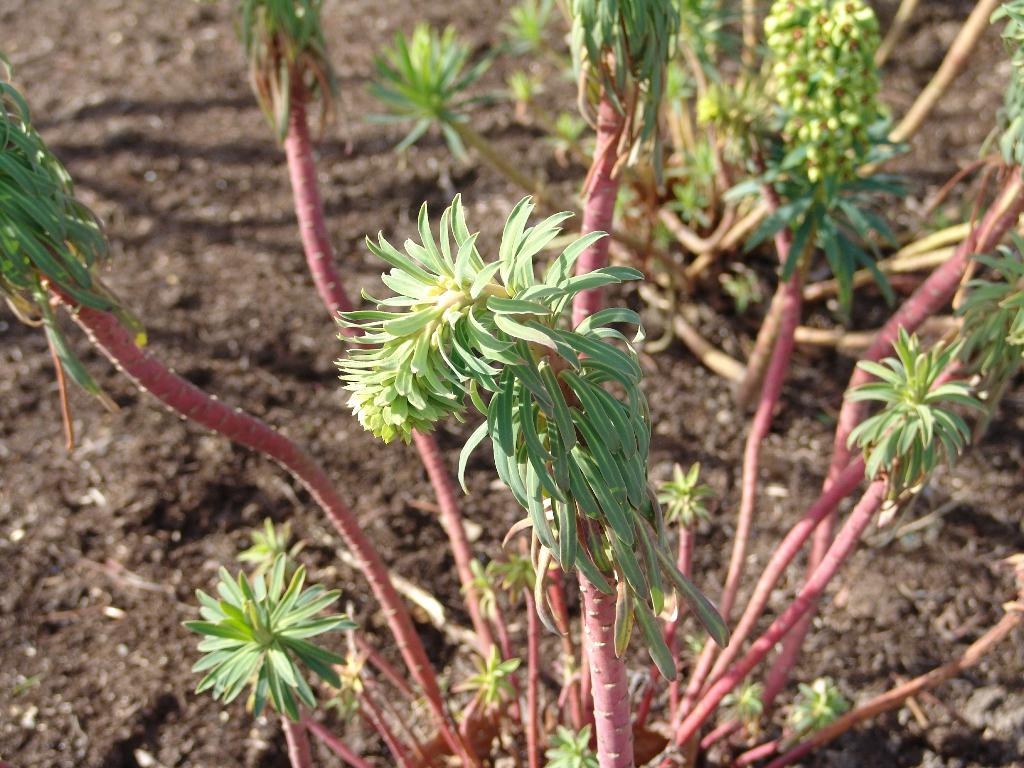What type of living organisms can be seen in the image? Plants can be seen in the image. What color are the leaves of the plants in the image? The leaves of the plants in the image have a green color. What color are the stems of the plants in the image? The stems of the plants in the image have a pink color. What can be seen at the bottom of the image? Mud is visible at the bottom of the image. What type of hill can be seen in the image? There is no hill present in the image; it features plants with green leaves and pink stems. Can you tell me the name of the manager of the goose in the image? There is no goose or manager present in the image; it only contains plants with green leaves and pink stems. 